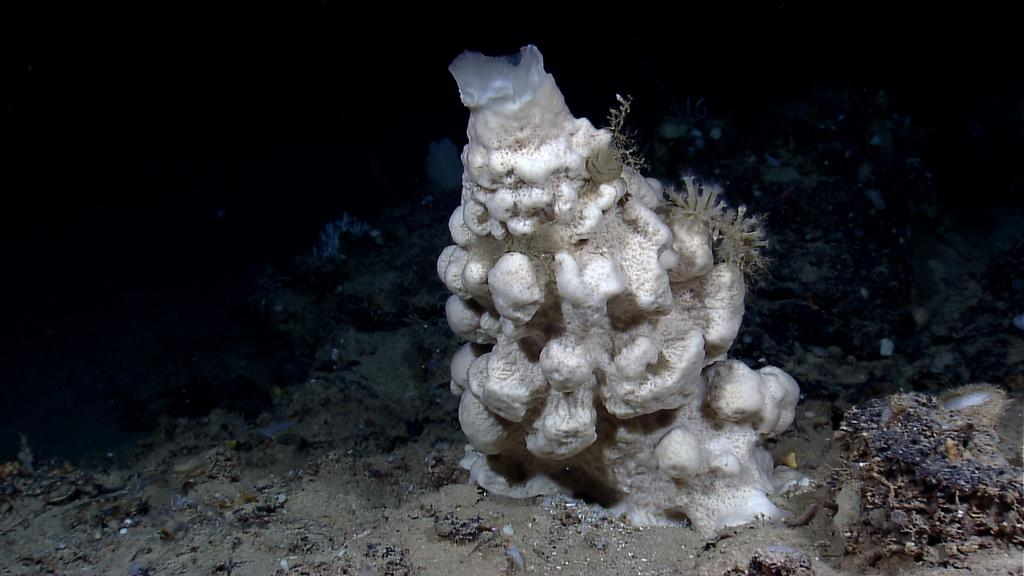What type of living organisms can be seen in the image? Plants can be seen in the image. What is the color of the background in the image? The background of the image is dark. What type of bread is the achiever eating in the image? There is no bread or achiever present in the image; it only features plants and a dark background. 